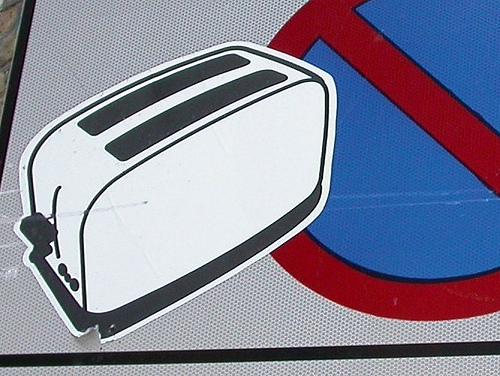What is write under the toaster?
Write a very short answer. Sign. What color is the toaster?
Short answer required. White. How many toast can you make at once?
Keep it brief. 2. What appliance is featured on the sign?
Quick response, please. Toaster. 